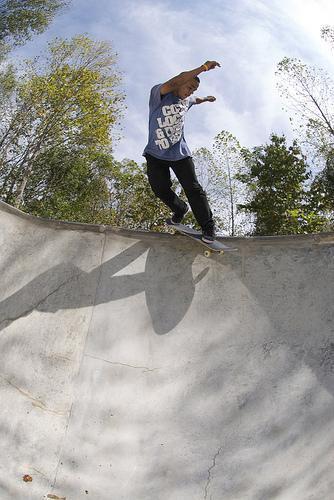How many kids are in the photo?
Give a very brief answer. 1. How many people are skating?
Give a very brief answer. 1. 